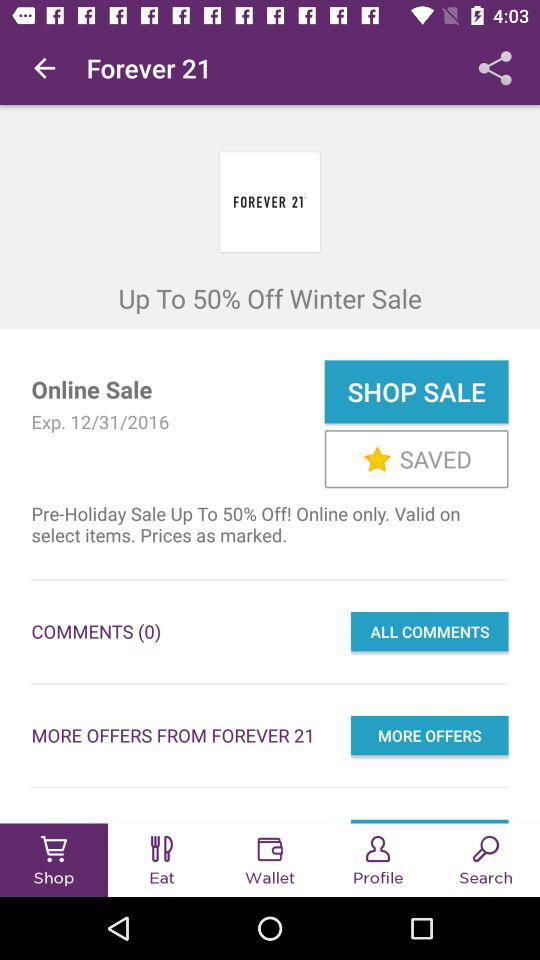How many offers are from Forever 21?
Answer the question using a single word or phrase. 1 